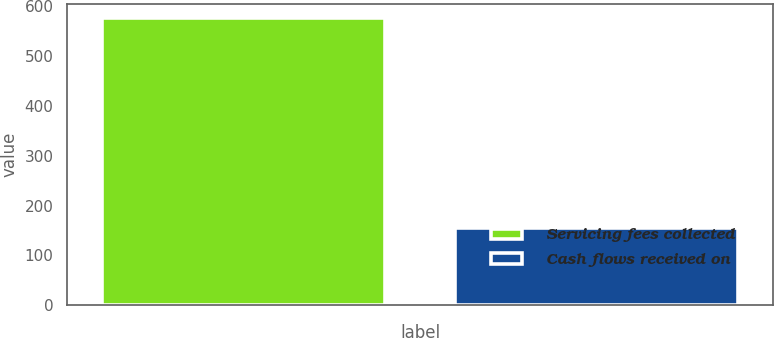<chart> <loc_0><loc_0><loc_500><loc_500><bar_chart><fcel>Servicing fees collected<fcel>Cash flows received on<nl><fcel>576<fcel>156<nl></chart> 